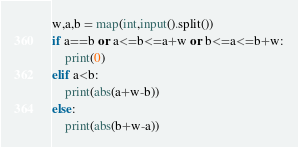Convert code to text. <code><loc_0><loc_0><loc_500><loc_500><_Python_>w,a,b = map(int,input().split())
if a==b or a<=b<=a+w or b<=a<=b+w:
    print(0)
elif a<b:
    print(abs(a+w-b))
else:
    print(abs(b+w-a))</code> 